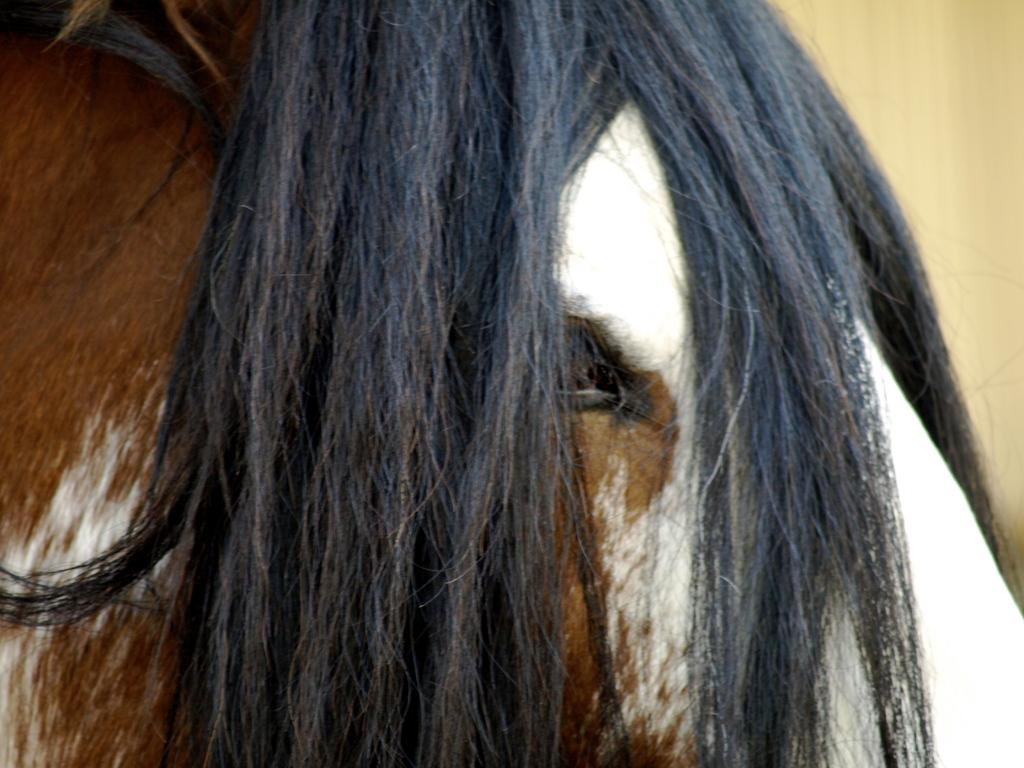What is the main subject of the image? The main subject of the image is the hair of a person. Can you describe the location of the hair in the image? The hair is located in the center of the image. What type of chalk is being used to draw on the pot in the image? There is no pot or chalk present in the image; it only features the hair of a person. How many snakes are visible in the image? There are no snakes present in the image; it only features the hair of a person. 